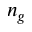Convert formula to latex. <formula><loc_0><loc_0><loc_500><loc_500>n _ { g }</formula> 